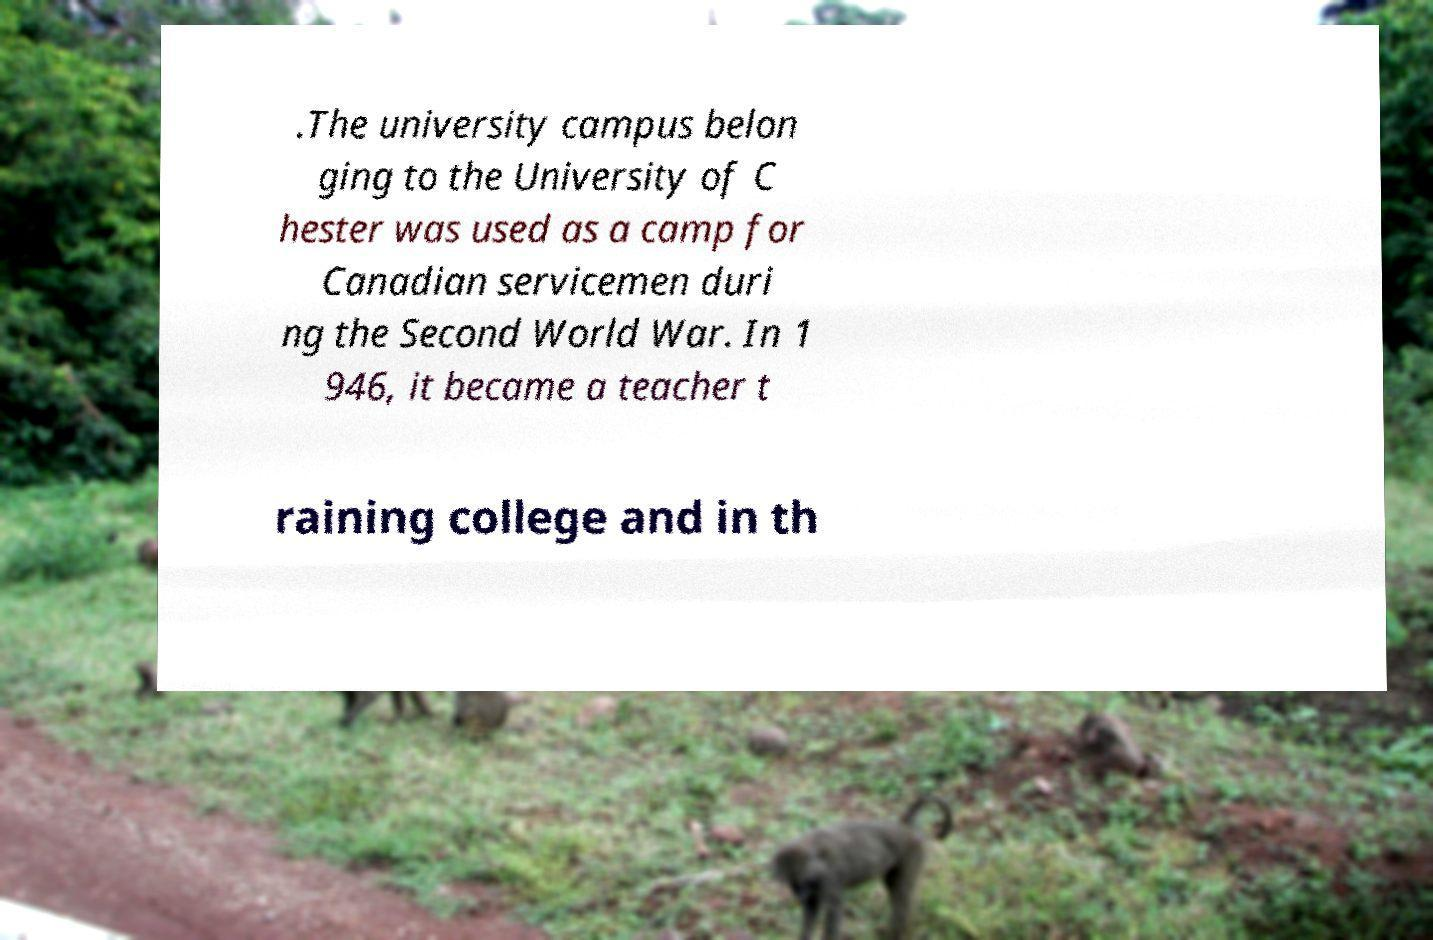I need the written content from this picture converted into text. Can you do that? .The university campus belon ging to the University of C hester was used as a camp for Canadian servicemen duri ng the Second World War. In 1 946, it became a teacher t raining college and in th 